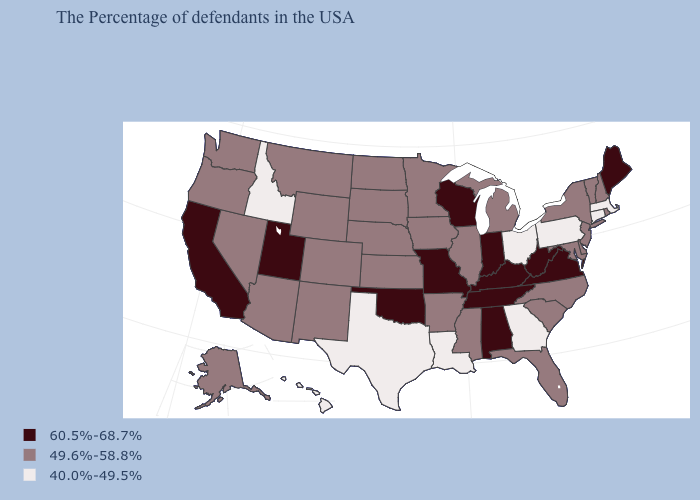What is the value of Alabama?
Answer briefly. 60.5%-68.7%. What is the value of New York?
Quick response, please. 49.6%-58.8%. What is the highest value in the USA?
Quick response, please. 60.5%-68.7%. What is the value of Virginia?
Quick response, please. 60.5%-68.7%. Name the states that have a value in the range 60.5%-68.7%?
Keep it brief. Maine, Virginia, West Virginia, Kentucky, Indiana, Alabama, Tennessee, Wisconsin, Missouri, Oklahoma, Utah, California. Name the states that have a value in the range 60.5%-68.7%?
Quick response, please. Maine, Virginia, West Virginia, Kentucky, Indiana, Alabama, Tennessee, Wisconsin, Missouri, Oklahoma, Utah, California. What is the value of Minnesota?
Short answer required. 49.6%-58.8%. What is the lowest value in the USA?
Be succinct. 40.0%-49.5%. Which states have the lowest value in the USA?
Give a very brief answer. Massachusetts, Connecticut, Pennsylvania, Ohio, Georgia, Louisiana, Texas, Idaho, Hawaii. Does Massachusetts have the lowest value in the Northeast?
Quick response, please. Yes. Name the states that have a value in the range 60.5%-68.7%?
Write a very short answer. Maine, Virginia, West Virginia, Kentucky, Indiana, Alabama, Tennessee, Wisconsin, Missouri, Oklahoma, Utah, California. Which states have the highest value in the USA?
Answer briefly. Maine, Virginia, West Virginia, Kentucky, Indiana, Alabama, Tennessee, Wisconsin, Missouri, Oklahoma, Utah, California. What is the value of Alaska?
Keep it brief. 49.6%-58.8%. How many symbols are there in the legend?
Give a very brief answer. 3. Which states have the lowest value in the USA?
Short answer required. Massachusetts, Connecticut, Pennsylvania, Ohio, Georgia, Louisiana, Texas, Idaho, Hawaii. 